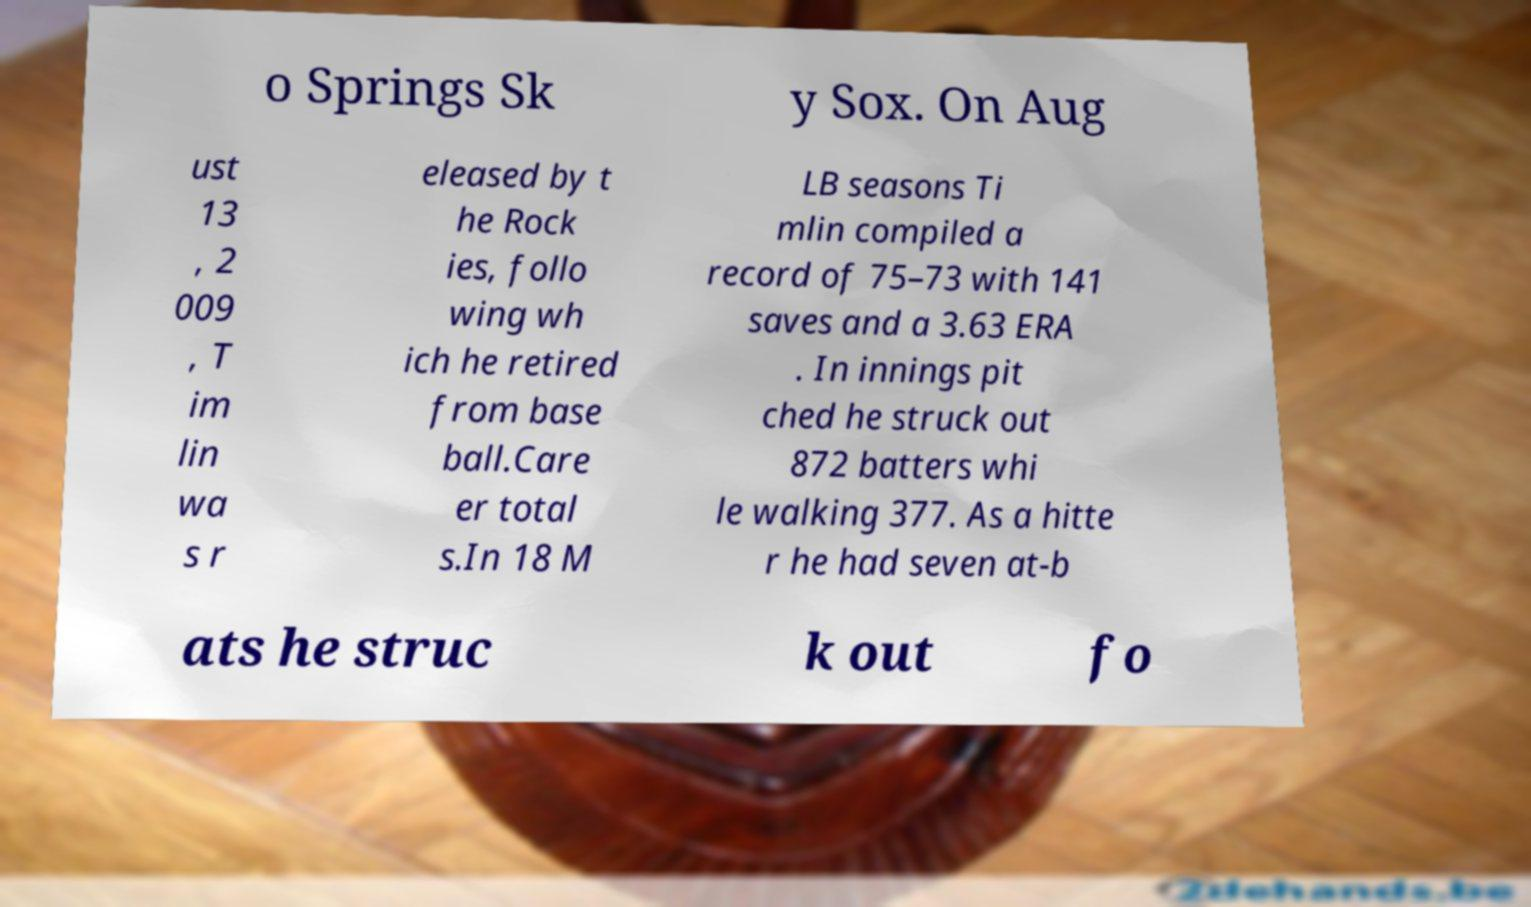Please read and relay the text visible in this image. What does it say? o Springs Sk y Sox. On Aug ust 13 , 2 009 , T im lin wa s r eleased by t he Rock ies, follo wing wh ich he retired from base ball.Care er total s.In 18 M LB seasons Ti mlin compiled a record of 75–73 with 141 saves and a 3.63 ERA . In innings pit ched he struck out 872 batters whi le walking 377. As a hitte r he had seven at-b ats he struc k out fo 